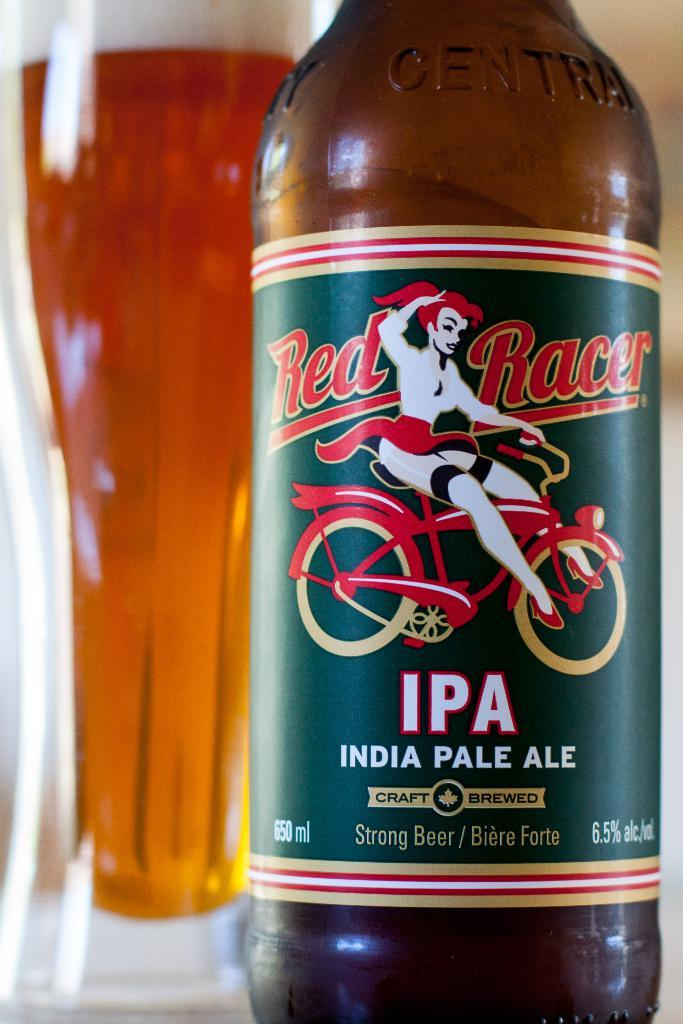Provide a one-sentence caption for the provided image. India Pale Ale brewed beer with a glass behind it. 